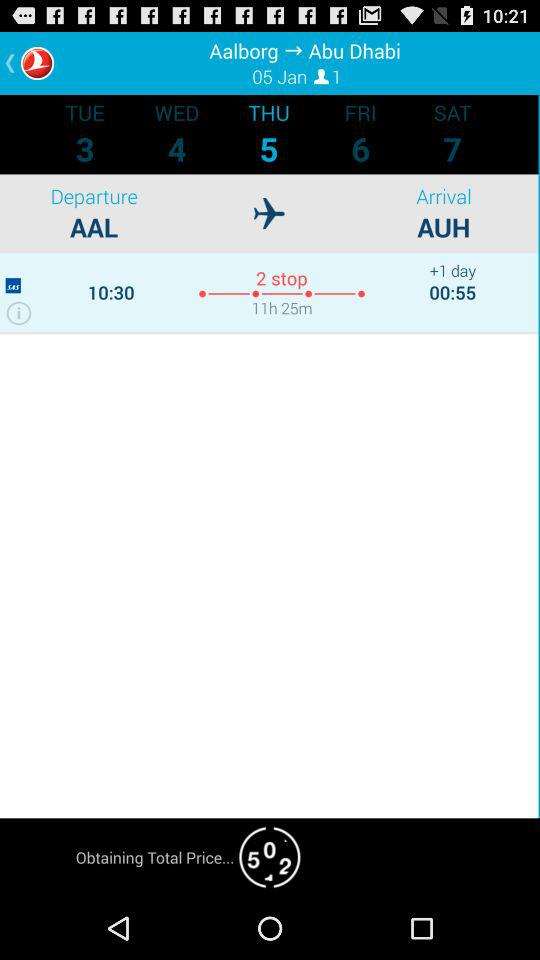What is the departure location? The departure location is Aalborg. 